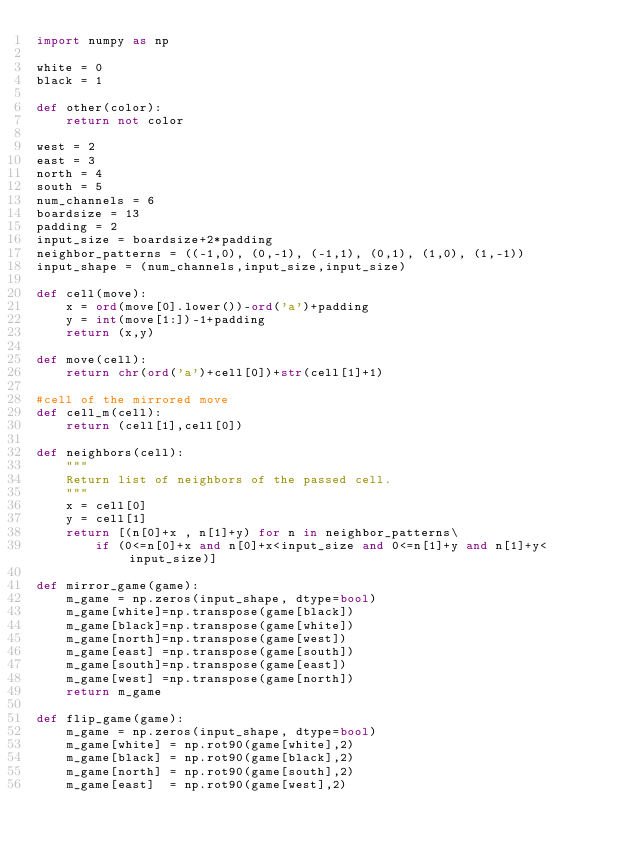Convert code to text. <code><loc_0><loc_0><loc_500><loc_500><_Python_>import numpy as np

white = 0
black = 1

def other(color):
	return not color

west = 2
east = 3
north = 4
south = 5
num_channels = 6
boardsize = 13
padding = 2
input_size = boardsize+2*padding
neighbor_patterns = ((-1,0), (0,-1), (-1,1), (0,1), (1,0), (1,-1))
input_shape = (num_channels,input_size,input_size)

def cell(move):
	x =	ord(move[0].lower())-ord('a')+padding
	y = int(move[1:])-1+padding
	return (x,y)

def move(cell):
	return chr(ord('a')+cell[0])+str(cell[1]+1)

#cell of the mirrored move
def cell_m(cell):
	return (cell[1],cell[0])

def neighbors(cell):
	"""
	Return list of neighbors of the passed cell.
	"""
	x = cell[0]
	y = cell[1]
	return [(n[0]+x , n[1]+y) for n in neighbor_patterns\
		if (0<=n[0]+x and n[0]+x<input_size and 0<=n[1]+y and n[1]+y<input_size)]

def mirror_game(game):
	m_game = np.zeros(input_shape, dtype=bool)
	m_game[white]=np.transpose(game[black])
	m_game[black]=np.transpose(game[white])
	m_game[north]=np.transpose(game[west])
	m_game[east] =np.transpose(game[south])
	m_game[south]=np.transpose(game[east])
	m_game[west] =np.transpose(game[north])
	return m_game

def flip_game(game):
	m_game = np.zeros(input_shape, dtype=bool)
	m_game[white] = np.rot90(game[white],2)
	m_game[black] = np.rot90(game[black],2)
	m_game[north] = np.rot90(game[south],2)
	m_game[east]  = np.rot90(game[west],2)</code> 